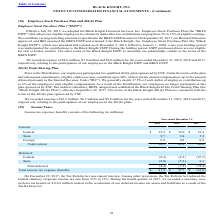From Black Knight Financial Services's financial document, Which years does the table provide information for the company's income tax expense (benefit)? The document contains multiple relevant values: 2019, 2018, 2017. From the document: "2019 2018 2017 2019 2018 2017 2019 2018 2017..." Also, When was the the Tax Reform Act signed into law?  According to the financial document, December 22, 2017. The relevant text states: "On December 22, 2017, the Tax Reform Act was signed into law. Among other provisions, the Tax Reform Act reduced the..." Also, What was the current federal income tax expense in 2019? According to the financial document, 39.5 (in millions). The relevant text states: "Current: Federal $ 39.5 $ 35.0 $ 10.4..." Also, How many years did current state income tax benefit exceed $8 million? Counting the relevant items in the document: 2019, 2018, I find 2 instances. The key data points involved are: 2018, 2019. Also, can you calculate: What was the change in the Total income tax expense between 2018 and 2019? Based on the calculation: 41.9-37.7, the result is 4.2 (in millions). This is based on the information: "Total income tax expense (benefit) $ 41.9 $ 37.7 $ (61.8) Total income tax expense (benefit) $ 41.9 $ 37.7 $ (61.8)..." The key data points involved are: 37.7, 41.9. Also, can you calculate: What was the percentage change in the total current income tax benefit between 2018 and 2019? To answer this question, I need to perform calculations using the financial data. The calculation is: (50.1-45.2)/45.2, which equals 10.84 (percentage). This is based on the information: "Total current 50.1 45.2 16.6 Total current 50.1 45.2 16.6..." The key data points involved are: 45.2, 50.1. 